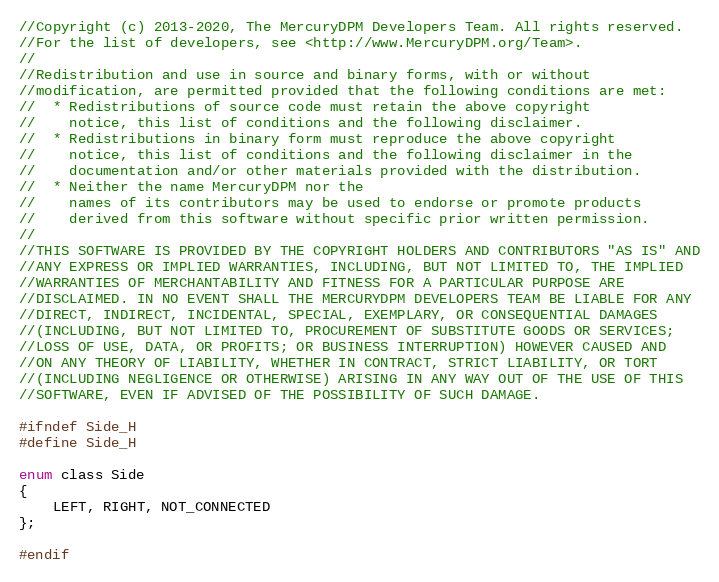<code> <loc_0><loc_0><loc_500><loc_500><_C_>//Copyright (c) 2013-2020, The MercuryDPM Developers Team. All rights reserved.
//For the list of developers, see <http://www.MercuryDPM.org/Team>.
//
//Redistribution and use in source and binary forms, with or without
//modification, are permitted provided that the following conditions are met:
//  * Redistributions of source code must retain the above copyright
//    notice, this list of conditions and the following disclaimer.
//  * Redistributions in binary form must reproduce the above copyright
//    notice, this list of conditions and the following disclaimer in the
//    documentation and/or other materials provided with the distribution.
//  * Neither the name MercuryDPM nor the
//    names of its contributors may be used to endorse or promote products
//    derived from this software without specific prior written permission.
//
//THIS SOFTWARE IS PROVIDED BY THE COPYRIGHT HOLDERS AND CONTRIBUTORS "AS IS" AND
//ANY EXPRESS OR IMPLIED WARRANTIES, INCLUDING, BUT NOT LIMITED TO, THE IMPLIED
//WARRANTIES OF MERCHANTABILITY AND FITNESS FOR A PARTICULAR PURPOSE ARE
//DISCLAIMED. IN NO EVENT SHALL THE MERCURYDPM DEVELOPERS TEAM BE LIABLE FOR ANY
//DIRECT, INDIRECT, INCIDENTAL, SPECIAL, EXEMPLARY, OR CONSEQUENTIAL DAMAGES
//(INCLUDING, BUT NOT LIMITED TO, PROCUREMENT OF SUBSTITUTE GOODS OR SERVICES;
//LOSS OF USE, DATA, OR PROFITS; OR BUSINESS INTERRUPTION) HOWEVER CAUSED AND
//ON ANY THEORY OF LIABILITY, WHETHER IN CONTRACT, STRICT LIABILITY, OR TORT
//(INCLUDING NEGLIGENCE OR OTHERWISE) ARISING IN ANY WAY OUT OF THE USE OF THIS
//SOFTWARE, EVEN IF ADVISED OF THE POSSIBILITY OF SUCH DAMAGE.

#ifndef Side_H
#define Side_H

enum class Side
{
    LEFT, RIGHT, NOT_CONNECTED
};

#endif
</code> 